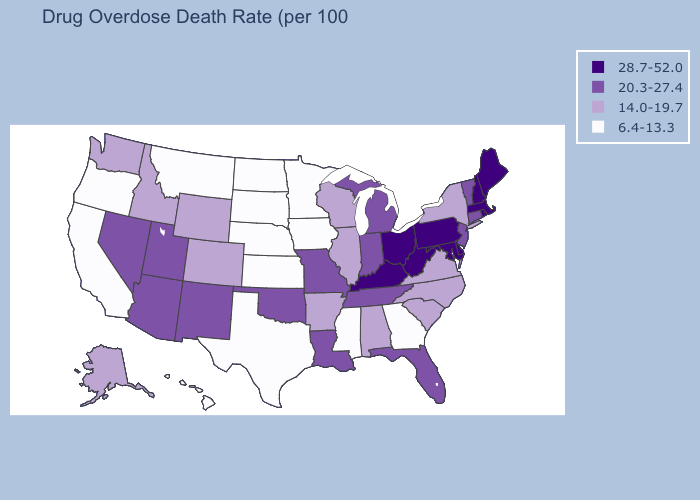What is the value of Tennessee?
Short answer required. 20.3-27.4. Which states have the highest value in the USA?
Concise answer only. Delaware, Kentucky, Maine, Maryland, Massachusetts, New Hampshire, Ohio, Pennsylvania, Rhode Island, West Virginia. What is the lowest value in the MidWest?
Write a very short answer. 6.4-13.3. Does Arizona have a higher value than Idaho?
Write a very short answer. Yes. What is the highest value in states that border Illinois?
Write a very short answer. 28.7-52.0. Which states have the lowest value in the USA?
Quick response, please. California, Georgia, Hawaii, Iowa, Kansas, Minnesota, Mississippi, Montana, Nebraska, North Dakota, Oregon, South Dakota, Texas. Does the map have missing data?
Write a very short answer. No. What is the value of Oregon?
Write a very short answer. 6.4-13.3. Name the states that have a value in the range 6.4-13.3?
Keep it brief. California, Georgia, Hawaii, Iowa, Kansas, Minnesota, Mississippi, Montana, Nebraska, North Dakota, Oregon, South Dakota, Texas. Does the map have missing data?
Be succinct. No. Does California have the highest value in the USA?
Quick response, please. No. What is the value of West Virginia?
Concise answer only. 28.7-52.0. Does Iowa have a higher value than Michigan?
Answer briefly. No. What is the value of New Mexico?
Quick response, please. 20.3-27.4. Name the states that have a value in the range 20.3-27.4?
Quick response, please. Arizona, Connecticut, Florida, Indiana, Louisiana, Michigan, Missouri, Nevada, New Jersey, New Mexico, Oklahoma, Tennessee, Utah, Vermont. 